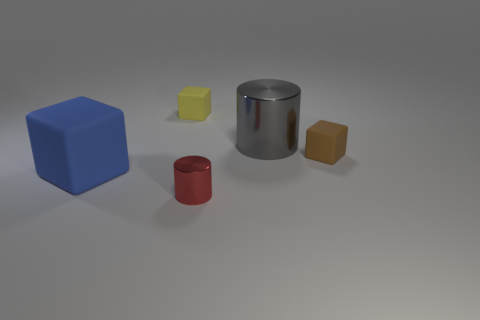There is a matte cube behind the small block that is to the right of the cylinder that is in front of the blue matte object; what color is it?
Offer a very short reply. Yellow. Is there any other thing that is the same color as the tiny cylinder?
Give a very brief answer. No. How big is the metallic cylinder that is in front of the gray metal object?
Offer a very short reply. Small. There is a gray shiny object that is the same size as the blue cube; what shape is it?
Ensure brevity in your answer.  Cylinder. Are the cylinder right of the red thing and the large object in front of the brown rubber thing made of the same material?
Provide a succinct answer. No. There is a small cube on the left side of the cylinder that is in front of the large gray cylinder; what is it made of?
Give a very brief answer. Rubber. There is a shiny object that is to the right of the shiny thing that is in front of the big blue thing left of the brown matte object; how big is it?
Your answer should be compact. Large. Do the yellow cube and the gray thing have the same size?
Provide a short and direct response. No. Is the shape of the blue matte thing in front of the small brown block the same as the big object that is right of the tiny red object?
Keep it short and to the point. No. Is there a blue block behind the shiny thing that is behind the big blue cube?
Give a very brief answer. No. 